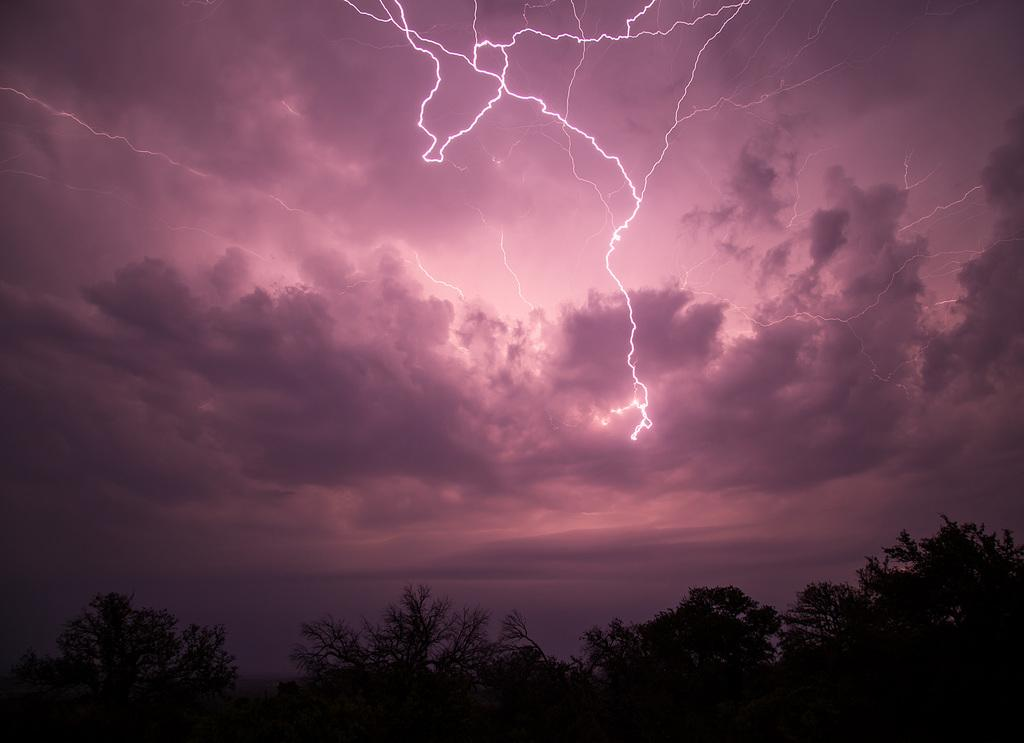What type of vegetation can be seen in the image? There are trees in the image. What is visible in the sky in the image? There are clouds and thunder in the sky. What type of amusement can be seen in the image? There is no amusement present in the image; it features trees and a sky with clouds and thunder. What color is the paint used on the trees in the image? There is no paint applied to the trees in the image; they are depicted in their natural colors. 